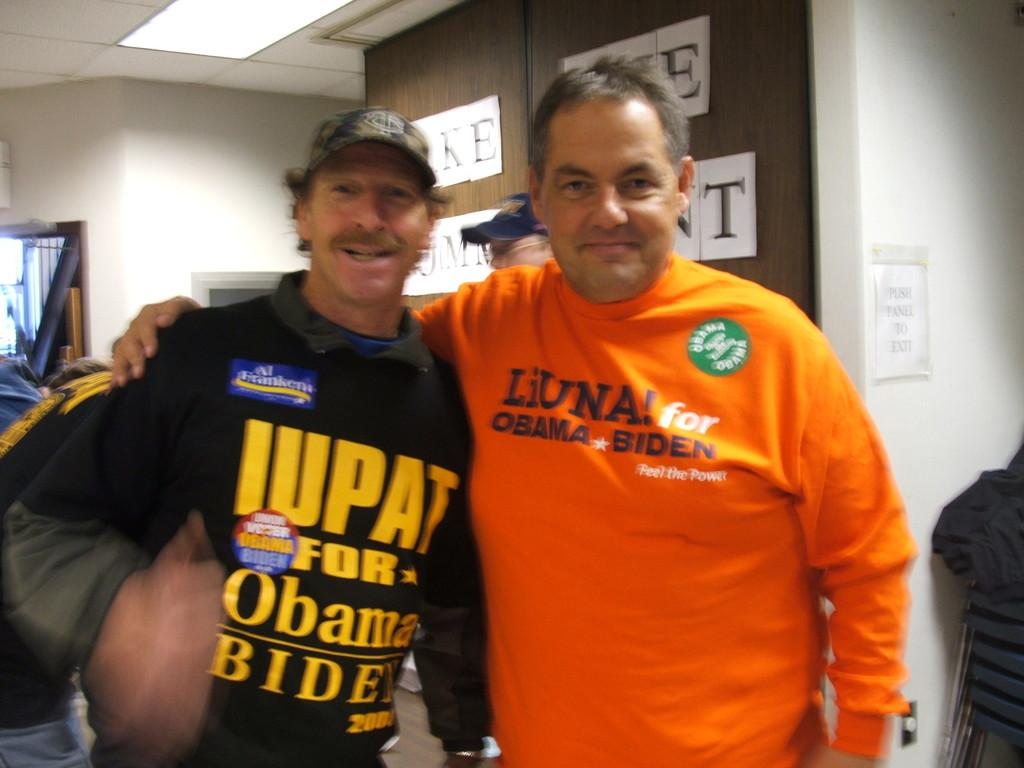<image>
Summarize the visual content of the image. a couple of guys and one with an Obama outfit on 